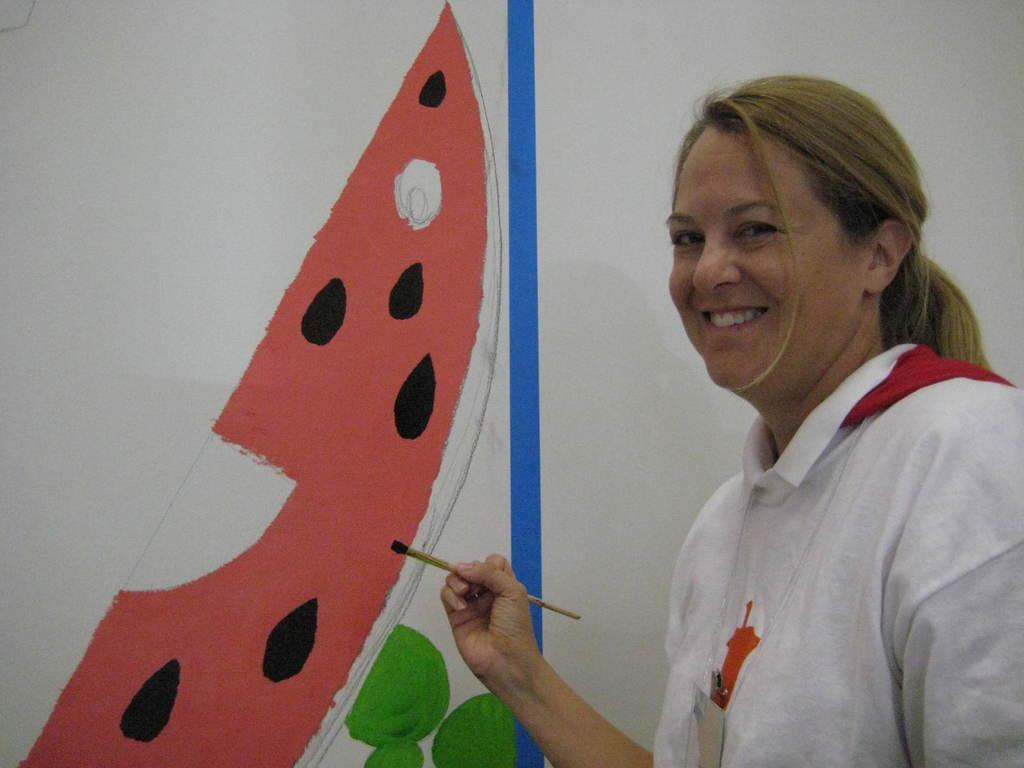Please provide a concise description of this image. In this image I can see person standing wearing white color shirt and the person is painting holding a brush. Background I can see the colorful painting and the wall is in white color. 